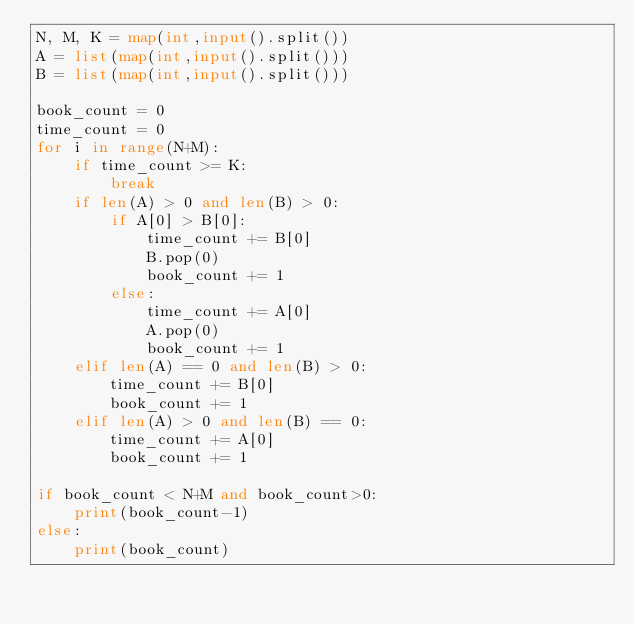Convert code to text. <code><loc_0><loc_0><loc_500><loc_500><_Python_>N, M, K = map(int,input().split())
A = list(map(int,input().split()))	
B = list(map(int,input().split()))	

book_count = 0
time_count = 0
for i in range(N+M):
    if time_count >= K:
        break
    if len(A) > 0 and len(B) > 0:
        if A[0] > B[0]:
            time_count += B[0]
            B.pop(0)
            book_count += 1
        else:
            time_count += A[0]
            A.pop(0)
            book_count += 1
    elif len(A) == 0 and len(B) > 0:
        time_count += B[0]
        book_count += 1
    elif len(A) > 0 and len(B) == 0:
        time_count += A[0]
        book_count += 1

if book_count < N+M and book_count>0:
    print(book_count-1)
else:
    print(book_count)</code> 